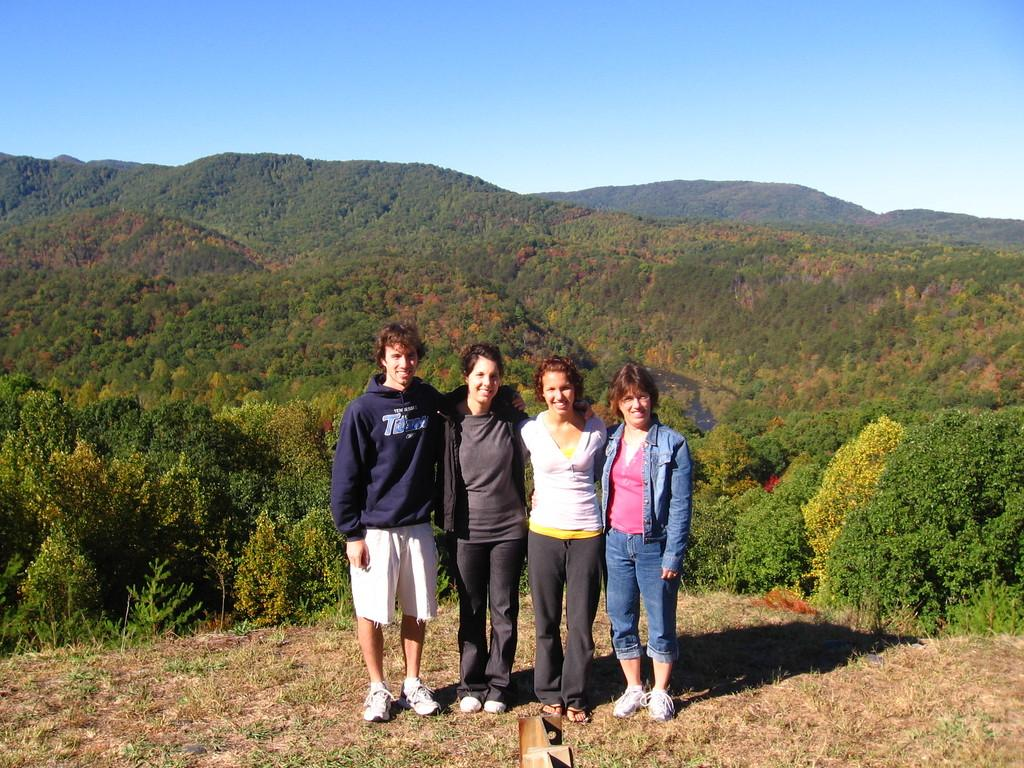How many people are in the image? There are four persons in the foreground of the image. What can be seen in the background of the image? Hills and trees are visible in the background of the image. What type of toothbrush is being used by the person on the left in the image? There is no toothbrush present in the image, as it features four persons in the foreground and hills and trees in the background. 